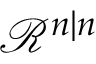Convert formula to latex. <formula><loc_0><loc_0><loc_500><loc_500>{ \mathcal { R } } ^ { n | n }</formula> 